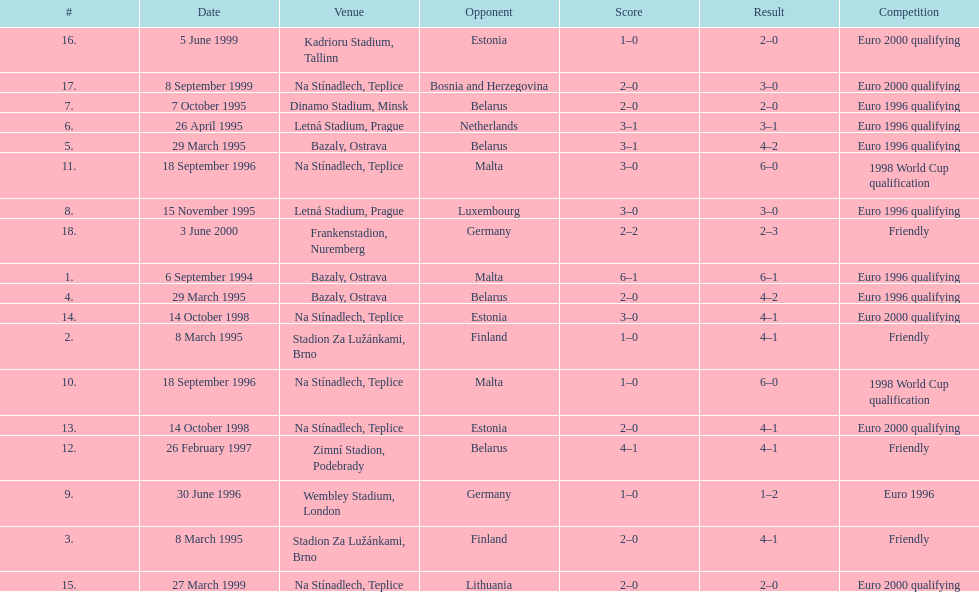How many euro 2000 qualifying competitions are listed? 4. 